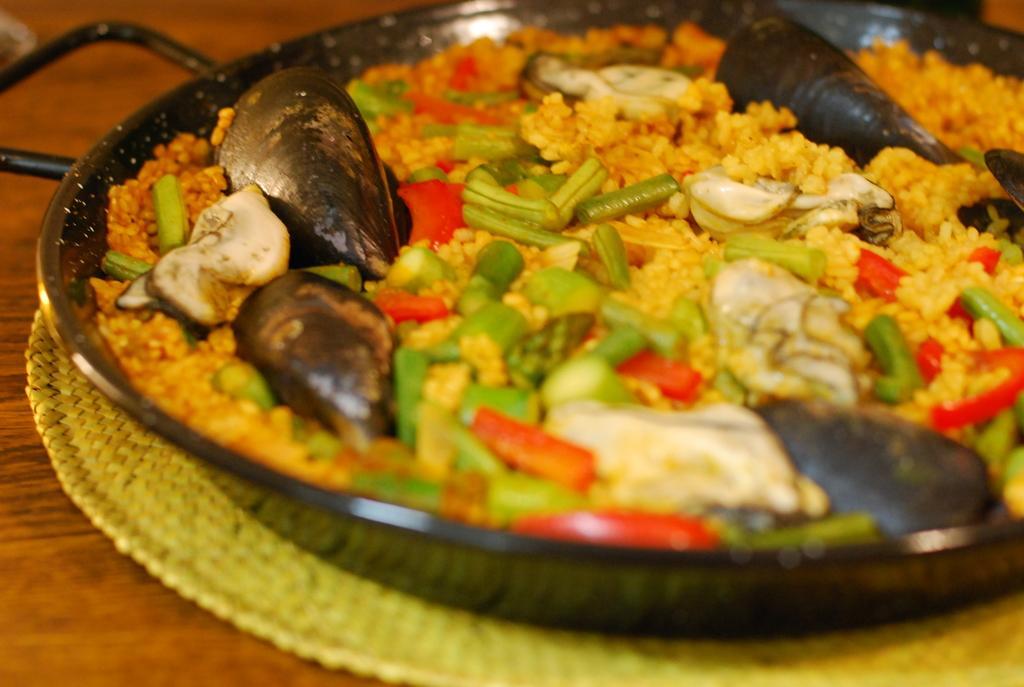Can you describe this image briefly? In this image we can see a pan on a mat. And the mat is on a wooden surface. In the pan there is a food item with vegetables, shells and many other things. 